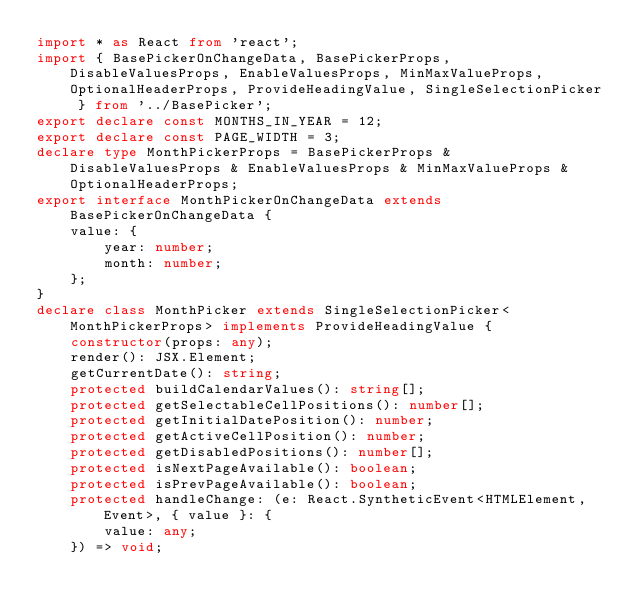Convert code to text. <code><loc_0><loc_0><loc_500><loc_500><_TypeScript_>import * as React from 'react';
import { BasePickerOnChangeData, BasePickerProps, DisableValuesProps, EnableValuesProps, MinMaxValueProps, OptionalHeaderProps, ProvideHeadingValue, SingleSelectionPicker } from '../BasePicker';
export declare const MONTHS_IN_YEAR = 12;
export declare const PAGE_WIDTH = 3;
declare type MonthPickerProps = BasePickerProps & DisableValuesProps & EnableValuesProps & MinMaxValueProps & OptionalHeaderProps;
export interface MonthPickerOnChangeData extends BasePickerOnChangeData {
    value: {
        year: number;
        month: number;
    };
}
declare class MonthPicker extends SingleSelectionPicker<MonthPickerProps> implements ProvideHeadingValue {
    constructor(props: any);
    render(): JSX.Element;
    getCurrentDate(): string;
    protected buildCalendarValues(): string[];
    protected getSelectableCellPositions(): number[];
    protected getInitialDatePosition(): number;
    protected getActiveCellPosition(): number;
    protected getDisabledPositions(): number[];
    protected isNextPageAvailable(): boolean;
    protected isPrevPageAvailable(): boolean;
    protected handleChange: (e: React.SyntheticEvent<HTMLElement, Event>, { value }: {
        value: any;
    }) => void;</code> 